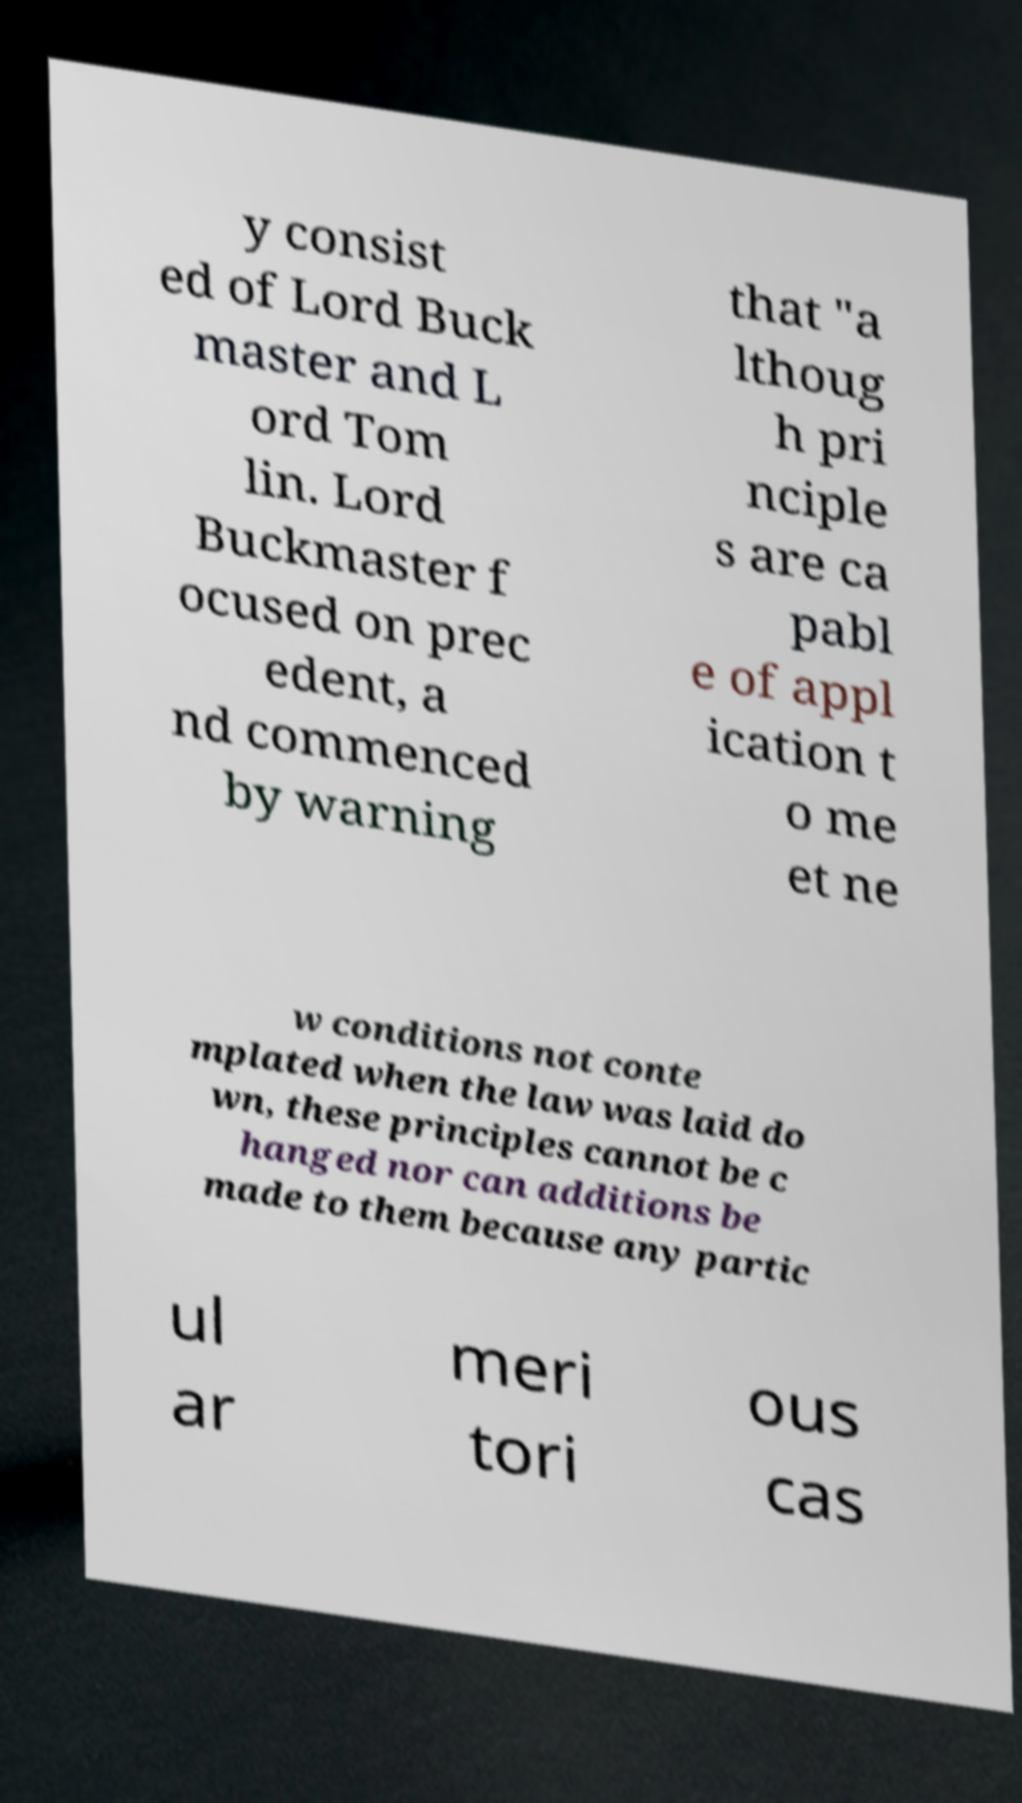There's text embedded in this image that I need extracted. Can you transcribe it verbatim? y consist ed of Lord Buck master and L ord Tom lin. Lord Buckmaster f ocused on prec edent, a nd commenced by warning that "a lthoug h pri nciple s are ca pabl e of appl ication t o me et ne w conditions not conte mplated when the law was laid do wn, these principles cannot be c hanged nor can additions be made to them because any partic ul ar meri tori ous cas 